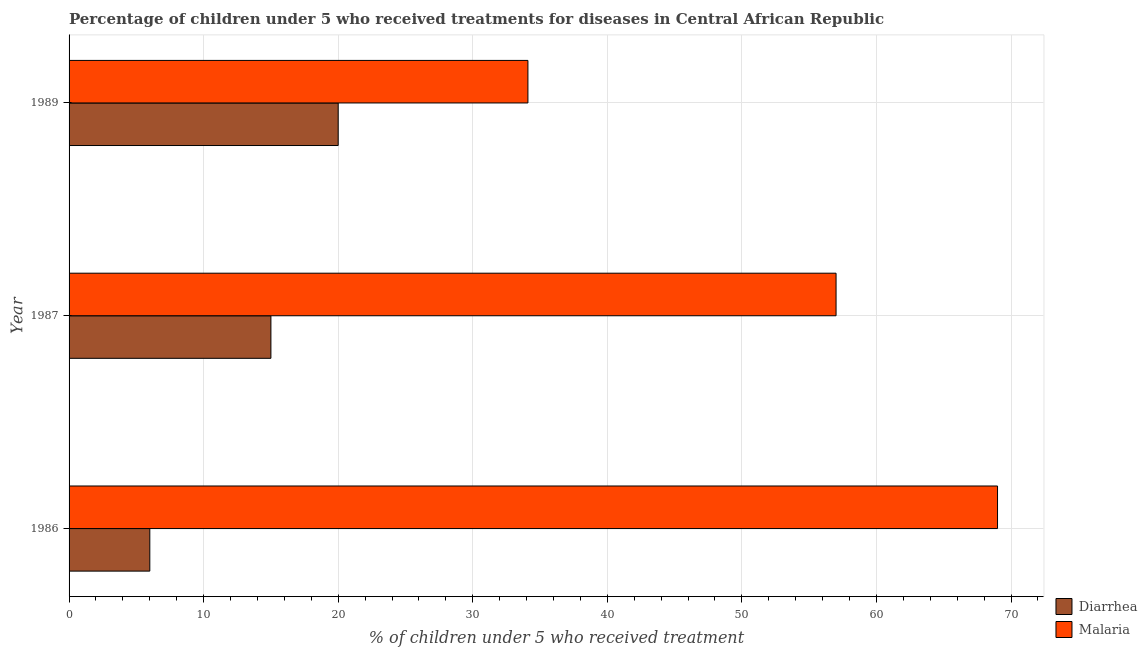How many groups of bars are there?
Provide a short and direct response. 3. Are the number of bars on each tick of the Y-axis equal?
Provide a short and direct response. Yes. How many bars are there on the 2nd tick from the top?
Your response must be concise. 2. What is the label of the 2nd group of bars from the top?
Give a very brief answer. 1987. In how many cases, is the number of bars for a given year not equal to the number of legend labels?
Offer a terse response. 0. Across all years, what is the maximum percentage of children who received treatment for diarrhoea?
Your response must be concise. 20. Across all years, what is the minimum percentage of children who received treatment for diarrhoea?
Offer a terse response. 6. In which year was the percentage of children who received treatment for diarrhoea minimum?
Offer a terse response. 1986. What is the total percentage of children who received treatment for diarrhoea in the graph?
Provide a short and direct response. 41. What is the difference between the percentage of children who received treatment for diarrhoea in 1986 and that in 1987?
Offer a terse response. -9. What is the difference between the percentage of children who received treatment for diarrhoea in 1987 and the percentage of children who received treatment for malaria in 1986?
Offer a terse response. -54. What is the average percentage of children who received treatment for diarrhoea per year?
Ensure brevity in your answer.  13.67. In the year 1987, what is the difference between the percentage of children who received treatment for diarrhoea and percentage of children who received treatment for malaria?
Offer a very short reply. -42. Is the difference between the percentage of children who received treatment for diarrhoea in 1986 and 1987 greater than the difference between the percentage of children who received treatment for malaria in 1986 and 1987?
Make the answer very short. No. What is the difference between the highest and the lowest percentage of children who received treatment for malaria?
Your answer should be very brief. 34.9. In how many years, is the percentage of children who received treatment for malaria greater than the average percentage of children who received treatment for malaria taken over all years?
Make the answer very short. 2. What does the 1st bar from the top in 1989 represents?
Make the answer very short. Malaria. What does the 2nd bar from the bottom in 1986 represents?
Your answer should be compact. Malaria. How many bars are there?
Provide a succinct answer. 6. Are all the bars in the graph horizontal?
Ensure brevity in your answer.  Yes. What is the difference between two consecutive major ticks on the X-axis?
Provide a succinct answer. 10. Are the values on the major ticks of X-axis written in scientific E-notation?
Ensure brevity in your answer.  No. Does the graph contain any zero values?
Provide a short and direct response. No. How many legend labels are there?
Offer a very short reply. 2. What is the title of the graph?
Offer a very short reply. Percentage of children under 5 who received treatments for diseases in Central African Republic. What is the label or title of the X-axis?
Your answer should be very brief. % of children under 5 who received treatment. What is the % of children under 5 who received treatment in Diarrhea in 1986?
Your answer should be very brief. 6. What is the % of children under 5 who received treatment of Malaria in 1986?
Provide a short and direct response. 69. What is the % of children under 5 who received treatment in Diarrhea in 1987?
Your response must be concise. 15. What is the % of children under 5 who received treatment in Malaria in 1989?
Make the answer very short. 34.1. Across all years, what is the maximum % of children under 5 who received treatment of Diarrhea?
Ensure brevity in your answer.  20. Across all years, what is the maximum % of children under 5 who received treatment in Malaria?
Your response must be concise. 69. Across all years, what is the minimum % of children under 5 who received treatment of Malaria?
Keep it short and to the point. 34.1. What is the total % of children under 5 who received treatment of Diarrhea in the graph?
Your answer should be very brief. 41. What is the total % of children under 5 who received treatment in Malaria in the graph?
Your response must be concise. 160.1. What is the difference between the % of children under 5 who received treatment of Malaria in 1986 and that in 1987?
Offer a very short reply. 12. What is the difference between the % of children under 5 who received treatment in Diarrhea in 1986 and that in 1989?
Your answer should be compact. -14. What is the difference between the % of children under 5 who received treatment in Malaria in 1986 and that in 1989?
Offer a very short reply. 34.9. What is the difference between the % of children under 5 who received treatment of Malaria in 1987 and that in 1989?
Ensure brevity in your answer.  22.9. What is the difference between the % of children under 5 who received treatment in Diarrhea in 1986 and the % of children under 5 who received treatment in Malaria in 1987?
Provide a succinct answer. -51. What is the difference between the % of children under 5 who received treatment in Diarrhea in 1986 and the % of children under 5 who received treatment in Malaria in 1989?
Your response must be concise. -28.1. What is the difference between the % of children under 5 who received treatment of Diarrhea in 1987 and the % of children under 5 who received treatment of Malaria in 1989?
Offer a very short reply. -19.1. What is the average % of children under 5 who received treatment in Diarrhea per year?
Keep it short and to the point. 13.67. What is the average % of children under 5 who received treatment in Malaria per year?
Make the answer very short. 53.37. In the year 1986, what is the difference between the % of children under 5 who received treatment in Diarrhea and % of children under 5 who received treatment in Malaria?
Offer a very short reply. -63. In the year 1987, what is the difference between the % of children under 5 who received treatment in Diarrhea and % of children under 5 who received treatment in Malaria?
Make the answer very short. -42. In the year 1989, what is the difference between the % of children under 5 who received treatment in Diarrhea and % of children under 5 who received treatment in Malaria?
Offer a very short reply. -14.1. What is the ratio of the % of children under 5 who received treatment of Malaria in 1986 to that in 1987?
Offer a very short reply. 1.21. What is the ratio of the % of children under 5 who received treatment of Diarrhea in 1986 to that in 1989?
Provide a succinct answer. 0.3. What is the ratio of the % of children under 5 who received treatment of Malaria in 1986 to that in 1989?
Ensure brevity in your answer.  2.02. What is the ratio of the % of children under 5 who received treatment in Diarrhea in 1987 to that in 1989?
Offer a very short reply. 0.75. What is the ratio of the % of children under 5 who received treatment of Malaria in 1987 to that in 1989?
Give a very brief answer. 1.67. What is the difference between the highest and the second highest % of children under 5 who received treatment in Diarrhea?
Offer a terse response. 5. What is the difference between the highest and the second highest % of children under 5 who received treatment of Malaria?
Your answer should be compact. 12. What is the difference between the highest and the lowest % of children under 5 who received treatment of Malaria?
Make the answer very short. 34.9. 